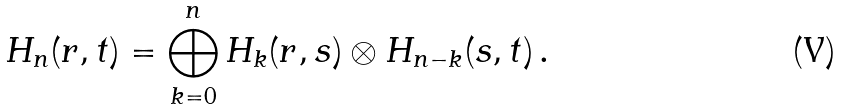Convert formula to latex. <formula><loc_0><loc_0><loc_500><loc_500>H _ { n } ( r , t ) = \bigoplus _ { k = 0 } ^ { n } H _ { k } ( r , s ) \otimes H _ { n - k } ( s , t ) \, .</formula> 